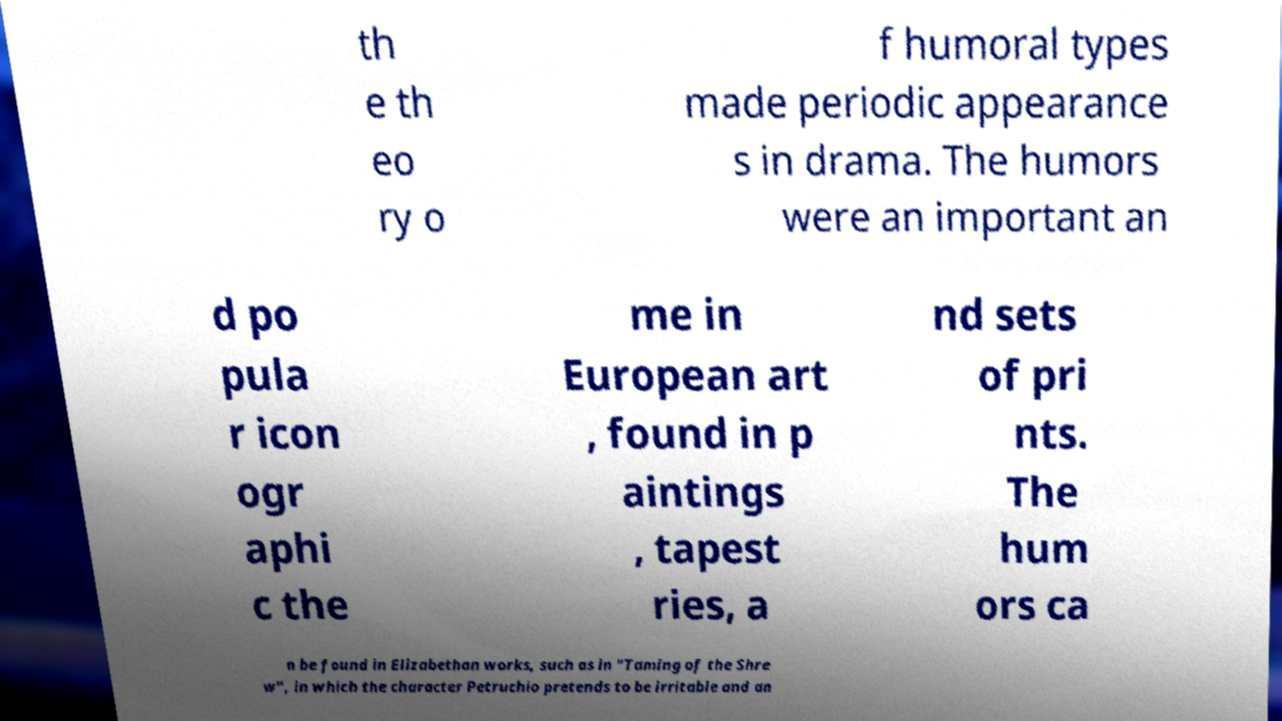For documentation purposes, I need the text within this image transcribed. Could you provide that? th e th eo ry o f humoral types made periodic appearance s in drama. The humors were an important an d po pula r icon ogr aphi c the me in European art , found in p aintings , tapest ries, a nd sets of pri nts. The hum ors ca n be found in Elizabethan works, such as in "Taming of the Shre w", in which the character Petruchio pretends to be irritable and an 